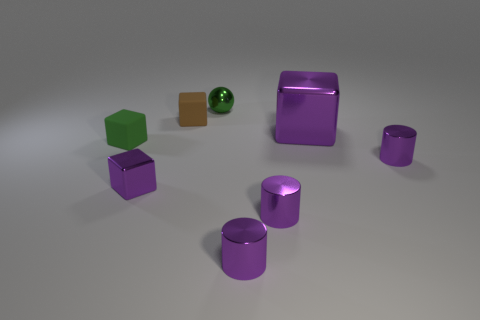What size is the object that is both on the left side of the small green shiny thing and behind the big purple shiny block?
Offer a very short reply. Small. What number of metallic objects are small yellow objects or green balls?
Offer a very short reply. 1. What is the big block made of?
Provide a short and direct response. Metal. The tiny cylinder that is behind the purple metal block that is in front of the purple cube on the right side of the tiny shiny sphere is made of what material?
Offer a very short reply. Metal. The brown thing that is the same size as the green cube is what shape?
Your answer should be very brief. Cube. What number of objects are tiny cyan matte objects or purple shiny objects that are in front of the green matte object?
Your answer should be very brief. 4. Is the material of the purple thing that is left of the tiny brown matte cube the same as the tiny cylinder that is on the right side of the big purple block?
Your response must be concise. Yes. What is the shape of the tiny object that is the same color as the tiny ball?
Give a very brief answer. Cube. How many green things are either tiny metallic cylinders or big shiny cubes?
Offer a terse response. 0. How big is the brown matte block?
Keep it short and to the point. Small. 